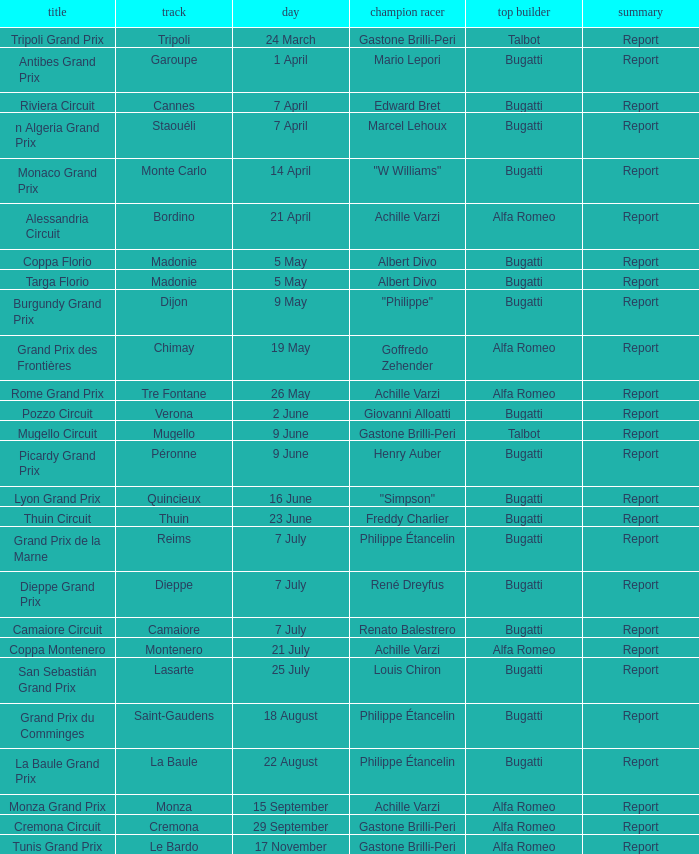What Date has a Name of thuin circuit? 23 June. 